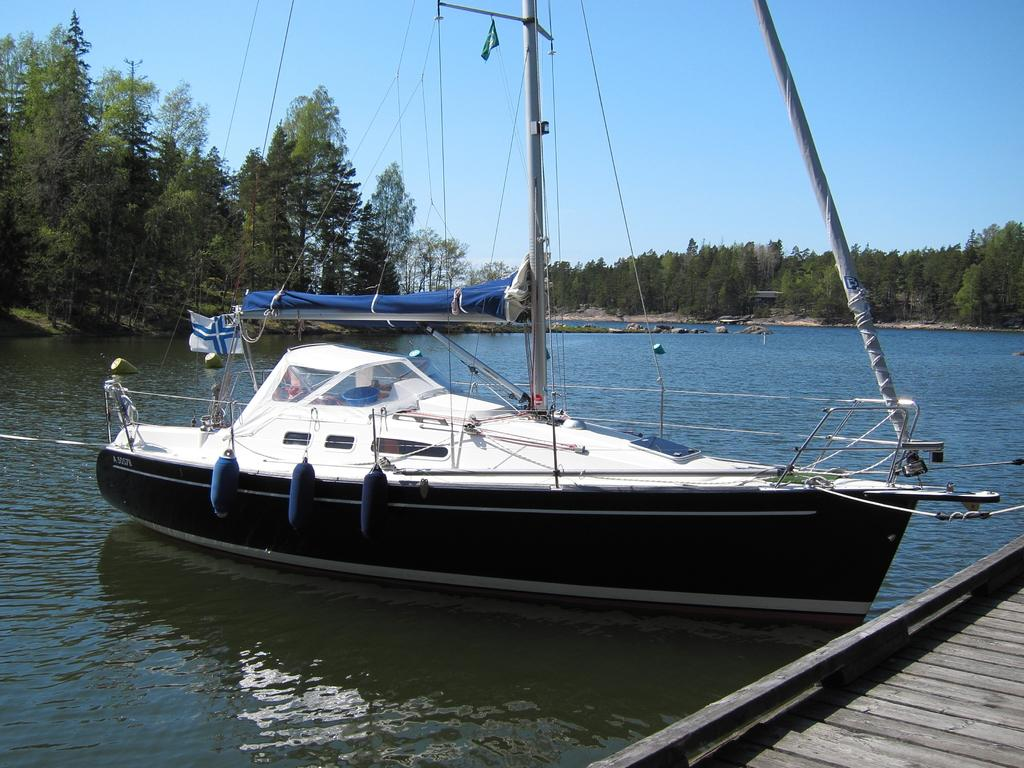What is the main subject of the image? The main subject of the image is a ship above the water. What other objects can be seen in the image? There are poles, strings, flags, and a bridge visible in the image. What is the background of the image? The background of the image includes trees and a blue sky. How many cows are present in the image? There are no cows present in the image. What is the temperature of the water in the image? The temperature of the water is not mentioned in the image, and it cannot be determined from the image alone. 